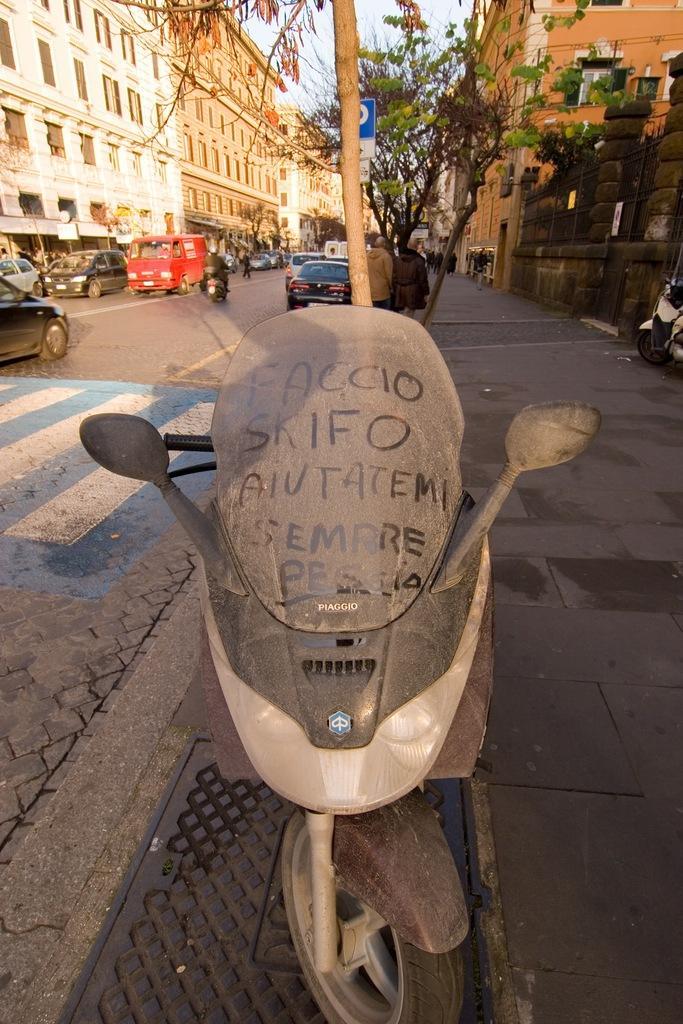Please provide a concise description of this image. This picture is clicked outside. In the center there is a car parked on the ground and we can see the group of vehicles seems to be running on the road and we can see the group of persons and the trees, houses, buildings, windows of the buildings. In the background there is a sky and many other objects. On the left corner we can see the zebra crossing. 